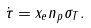<formula> <loc_0><loc_0><loc_500><loc_500>\dot { \tau } = x _ { e } n _ { p } \sigma _ { T } .</formula> 